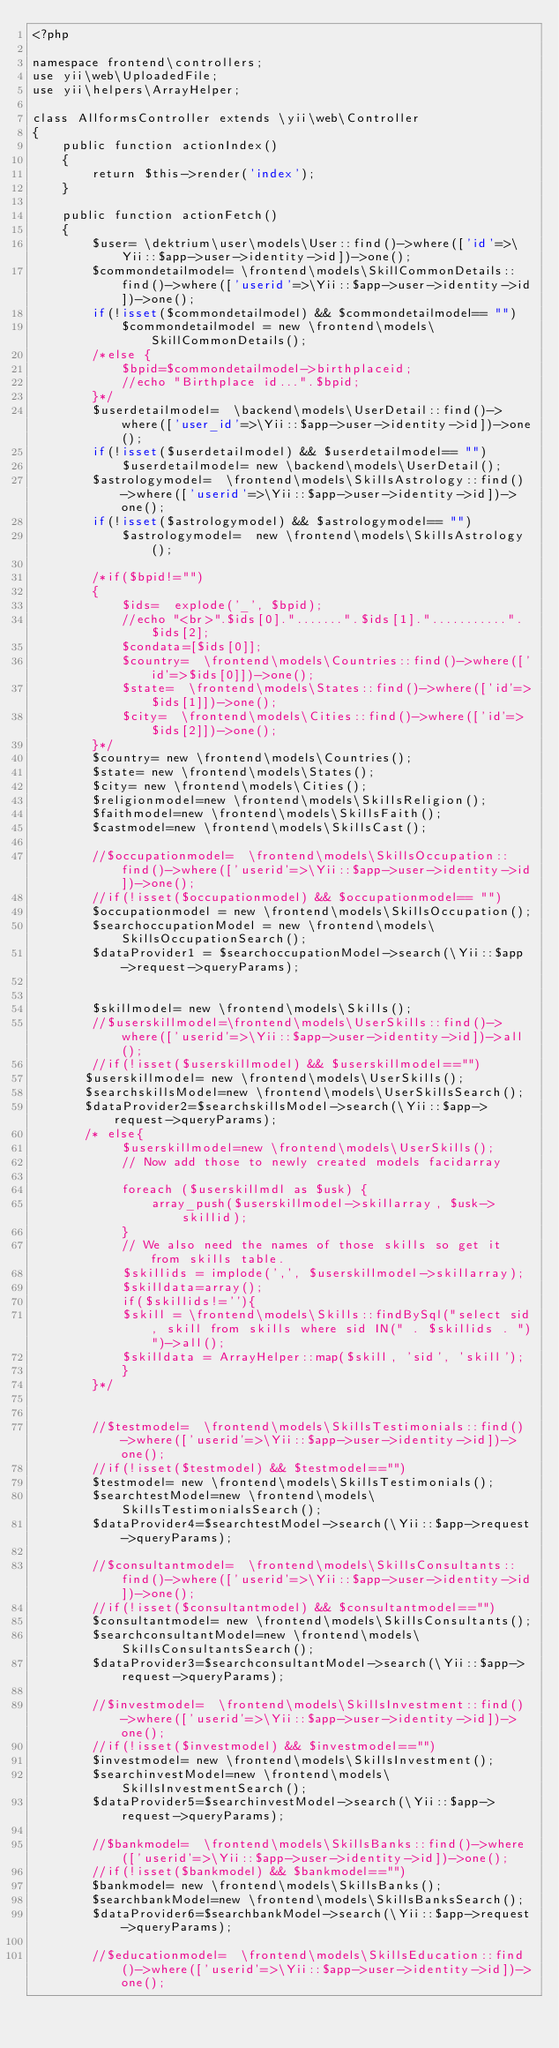<code> <loc_0><loc_0><loc_500><loc_500><_PHP_><?php

namespace frontend\controllers;
use yii\web\UploadedFile;
use yii\helpers\ArrayHelper;

class AllformsController extends \yii\web\Controller
{
    public function actionIndex()
    {
        return $this->render('index');
    }

    public function actionFetch()
    {
        $user= \dektrium\user\models\User::find()->where(['id'=>\Yii::$app->user->identity->id])->one();
        $commondetailmodel= \frontend\models\SkillCommonDetails::find()->where(['userid'=>\Yii::$app->user->identity->id])->one();
        if(!isset($commondetailmodel) && $commondetailmodel== "")
            $commondetailmodel = new \frontend\models\SkillCommonDetails();
        /*else {
            $bpid=$commondetailmodel->birthplaceid;
            //echo "Birthplace id...".$bpid;
        }*/
        $userdetailmodel=  \backend\models\UserDetail::find()->where(['user_id'=>\Yii::$app->user->identity->id])->one();
        if(!isset($userdetailmodel) && $userdetailmodel== "")
            $userdetailmodel= new \backend\models\UserDetail();
        $astrologymodel=  \frontend\models\SkillsAstrology::find()->where(['userid'=>\Yii::$app->user->identity->id])->one();
        if(!isset($astrologymodel) && $astrologymodel== "")
            $astrologymodel=  new \frontend\models\SkillsAstrology();
        
        /*if($bpid!="")
        {
            $ids=  explode('_', $bpid);
            //echo "<br>".$ids[0].".......".$ids[1]."...........".$ids[2];
            $condata=[$ids[0]];
            $country=  \frontend\models\Countries::find()->where(['id'=>$ids[0]])->one();
            $state=  \frontend\models\States::find()->where(['id'=>$ids[1]])->one();
            $city=  \frontend\models\Cities::find()->where(['id'=>$ids[2]])->one();                   
        }*/
        $country= new \frontend\models\Countries();            
        $state= new \frontend\models\States();
        $city= new \frontend\models\Cities();
        $religionmodel=new \frontend\models\SkillsReligion();
        $faithmodel=new \frontend\models\SkillsFaith();
        $castmodel=new \frontend\models\SkillsCast();
            
        //$occupationmodel=  \frontend\models\SkillsOccupation::find()->where(['userid'=>\Yii::$app->user->identity->id])->one();
        //if(!isset($occupationmodel) && $occupationmodel== "")
        $occupationmodel = new \frontend\models\SkillsOccupation();
        $searchoccupationModel = new \frontend\models\SkillsOccupationSearch();
        $dataProvider1 = $searchoccupationModel->search(\Yii::$app->request->queryParams);
        
        
        $skillmodel= new \frontend\models\Skills();
        //$userskillmodel=\frontend\models\UserSkills::find()->where(['userid'=>\Yii::$app->user->identity->id])->all();
        //if(!isset($userskillmodel) && $userskillmodel=="")         
       $userskillmodel= new \frontend\models\UserSkills();
       $searchskillsModel=new \frontend\models\UserSkillsSearch();
       $dataProvider2=$searchskillsModel->search(\Yii::$app->request->queryParams);
       /* else{
            $userskillmodel=new \frontend\models\UserSkills();
            // Now add those to newly created models facidarray

            foreach ($userskillmdl as $usk) {           
                array_push($userskillmodel->skillarray, $usk->skillid);
            }
            // We also need the names of those skills so get it from skills table.        
            $skillids = implode(',', $userskillmodel->skillarray); 
            $skilldata=array();
            if($skillids!=''){
            $skill = \frontend\models\Skills::findBySql("select sid, skill from skills where sid IN(" . $skillids . ")")->all();
            $skilldata = ArrayHelper::map($skill, 'sid', 'skill');
            }
        }*/
        
        
        //$testmodel=  \frontend\models\SkillsTestimonials::find()->where(['userid'=>\Yii::$app->user->identity->id])->one();
        //if(!isset($testmodel) && $testmodel=="") 
        $testmodel= new \frontend\models\SkillsTestimonials();
        $searchtestModel=new \frontend\models\SkillsTestimonialsSearch();
        $dataProvider4=$searchtestModel->search(\Yii::$app->request->queryParams);
        
        //$consultantmodel=  \frontend\models\SkillsConsultants::find()->where(['userid'=>\Yii::$app->user->identity->id])->one();
        //if(!isset($consultantmodel) && $consultantmodel=="") 
        $consultantmodel= new \frontend\models\SkillsConsultants();
        $searchconsultantModel=new \frontend\models\SkillsConsultantsSearch();
        $dataProvider3=$searchconsultantModel->search(\Yii::$app->request->queryParams);
        
        //$investmodel=  \frontend\models\SkillsInvestment::find()->where(['userid'=>\Yii::$app->user->identity->id])->one();
        //if(!isset($investmodel) && $investmodel=="") 
        $investmodel= new \frontend\models\SkillsInvestment();
        $searchinvestModel=new \frontend\models\SkillsInvestmentSearch();
        $dataProvider5=$searchinvestModel->search(\Yii::$app->request->queryParams);
        
        //$bankmodel=  \frontend\models\SkillsBanks::find()->where(['userid'=>\Yii::$app->user->identity->id])->one();
        //if(!isset($bankmodel) && $bankmodel=="") 
        $bankmodel= new \frontend\models\SkillsBanks();
        $searchbankModel=new \frontend\models\SkillsBanksSearch();
        $dataProvider6=$searchbankModel->search(\Yii::$app->request->queryParams);
        
        //$educationmodel=  \frontend\models\SkillsEducation::find()->where(['userid'=>\Yii::$app->user->identity->id])->one();</code> 